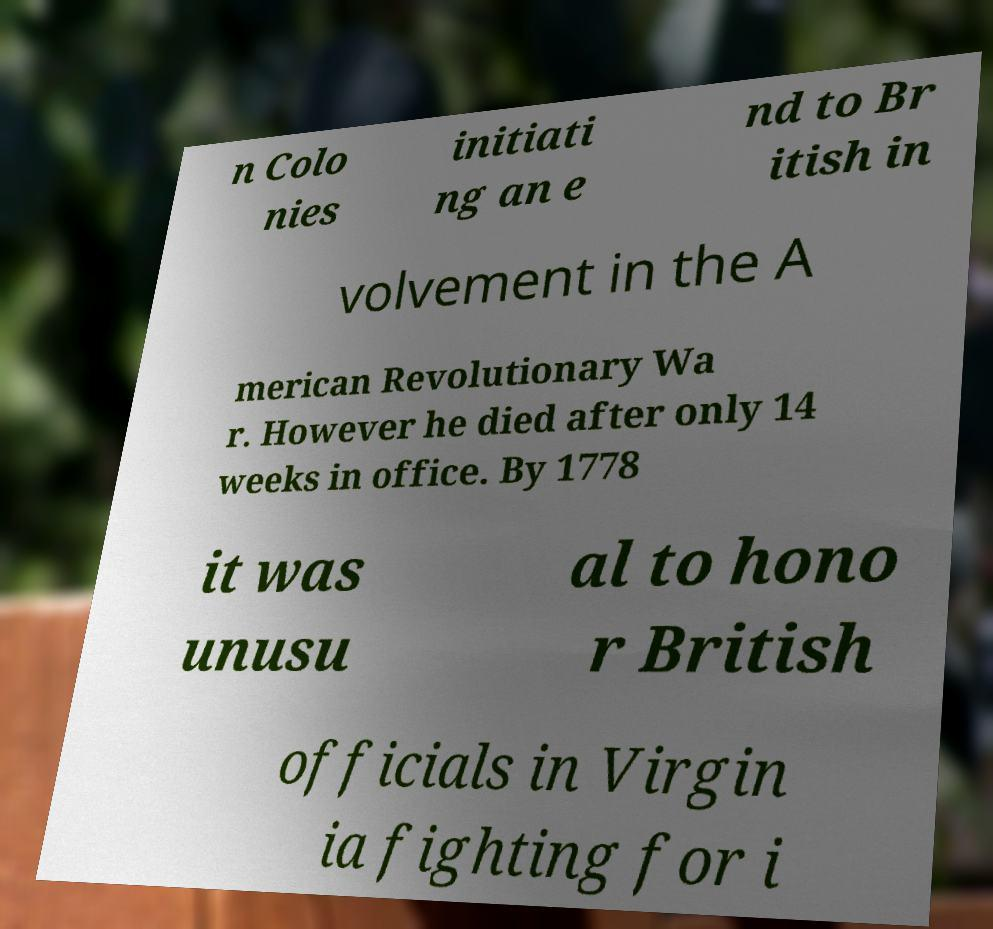Can you accurately transcribe the text from the provided image for me? n Colo nies initiati ng an e nd to Br itish in volvement in the A merican Revolutionary Wa r. However he died after only 14 weeks in office. By 1778 it was unusu al to hono r British officials in Virgin ia fighting for i 